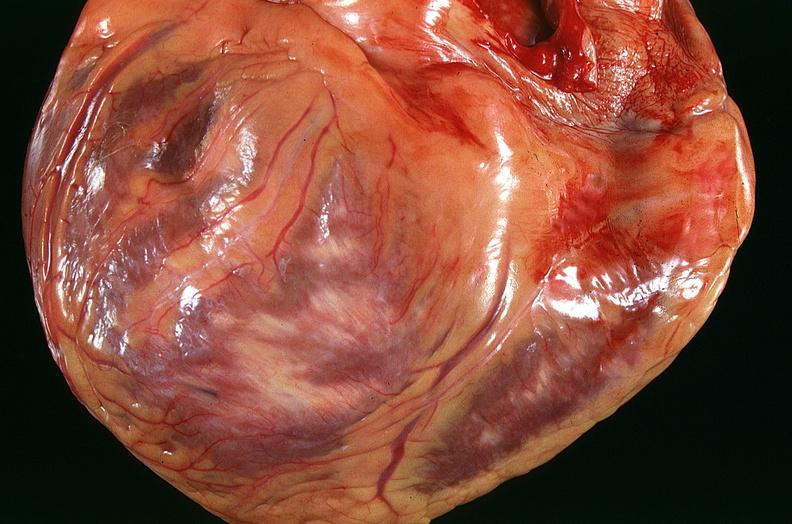does this image show congestive heart failure, three vessel coronary artery disease?
Answer the question using a single word or phrase. Yes 